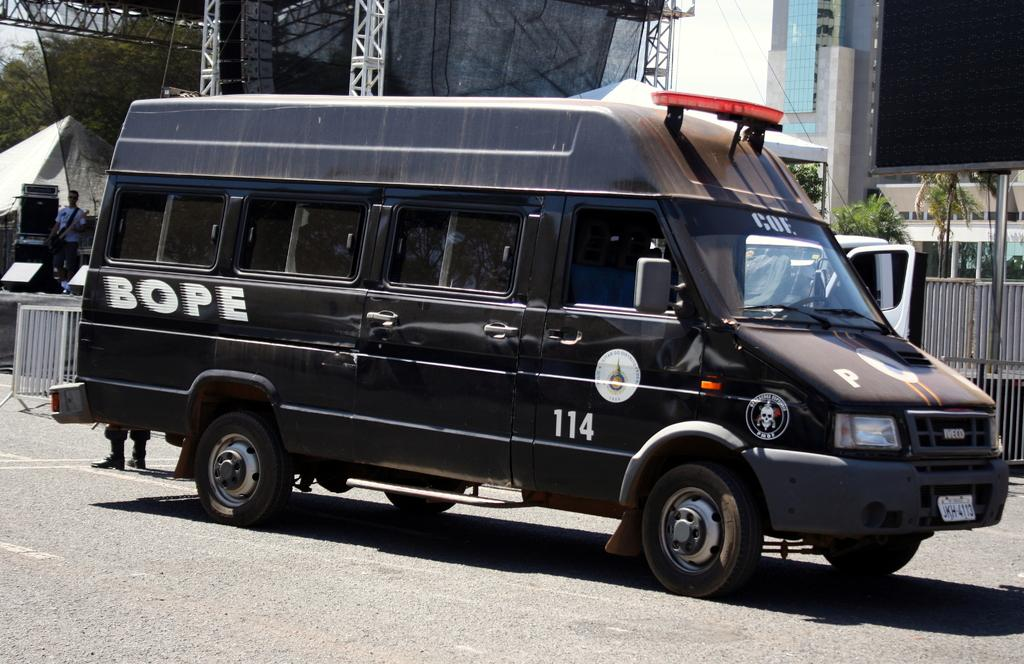What type of vehicle is on the road in the image? There is a black color van on the road in the image. What can be seen behind the van? There is a building behind the van. What other objects are visible in the background? There is a pole, a board, and trees in the background. What is on the left side of the image? There is a fencing on the left side of the image. Is there anyone near the fencing? Yes, a man is standing near the fencing. What type of butter is being used to paint the board in the image? There is no butter present in the image, and the board is not being painted. 